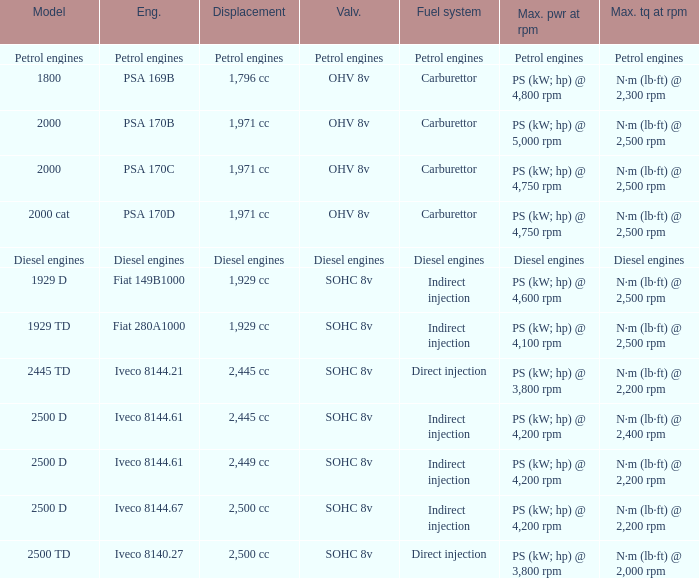What is the maximum torque that has 2,445 CC Displacement, and an Iveco 8144.61 engine? N·m (lb·ft) @ 2,400 rpm. 